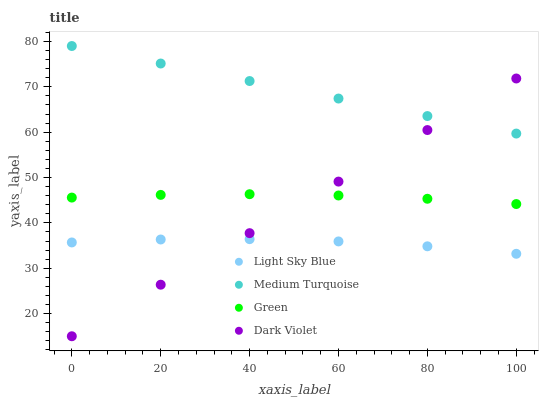Does Light Sky Blue have the minimum area under the curve?
Answer yes or no. Yes. Does Medium Turquoise have the maximum area under the curve?
Answer yes or no. Yes. Does Green have the minimum area under the curve?
Answer yes or no. No. Does Green have the maximum area under the curve?
Answer yes or no. No. Is Dark Violet the smoothest?
Answer yes or no. Yes. Is Light Sky Blue the roughest?
Answer yes or no. Yes. Is Green the smoothest?
Answer yes or no. No. Is Green the roughest?
Answer yes or no. No. Does Dark Violet have the lowest value?
Answer yes or no. Yes. Does Green have the lowest value?
Answer yes or no. No. Does Medium Turquoise have the highest value?
Answer yes or no. Yes. Does Green have the highest value?
Answer yes or no. No. Is Green less than Medium Turquoise?
Answer yes or no. Yes. Is Medium Turquoise greater than Light Sky Blue?
Answer yes or no. Yes. Does Medium Turquoise intersect Dark Violet?
Answer yes or no. Yes. Is Medium Turquoise less than Dark Violet?
Answer yes or no. No. Is Medium Turquoise greater than Dark Violet?
Answer yes or no. No. Does Green intersect Medium Turquoise?
Answer yes or no. No. 